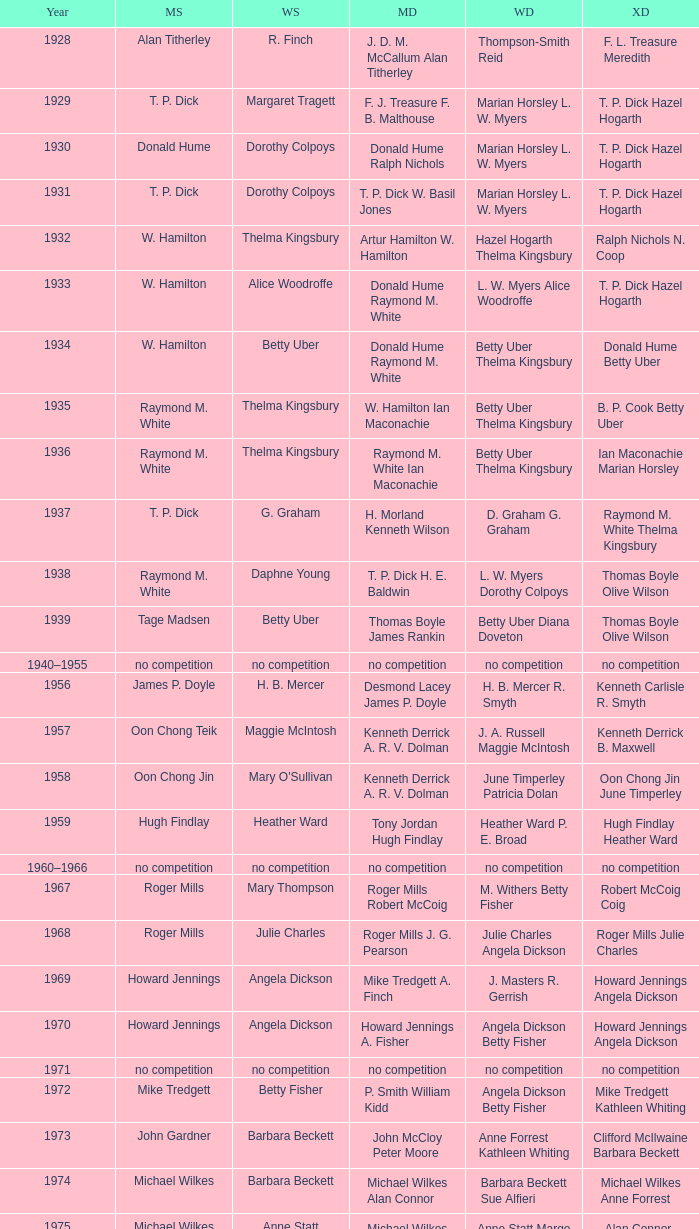In the year when david eddy eddy sutton clinched the men's doubles title and david eddy secured the men's singles championship, who were the victors in the women's doubles event? Anne Statt Jane Webster. Give me the full table as a dictionary. {'header': ['Year', 'MS', 'WS', 'MD', 'WD', 'XD'], 'rows': [['1928', 'Alan Titherley', 'R. Finch', 'J. D. M. McCallum Alan Titherley', 'Thompson-Smith Reid', 'F. L. Treasure Meredith'], ['1929', 'T. P. Dick', 'Margaret Tragett', 'F. J. Treasure F. B. Malthouse', 'Marian Horsley L. W. Myers', 'T. P. Dick Hazel Hogarth'], ['1930', 'Donald Hume', 'Dorothy Colpoys', 'Donald Hume Ralph Nichols', 'Marian Horsley L. W. Myers', 'T. P. Dick Hazel Hogarth'], ['1931', 'T. P. Dick', 'Dorothy Colpoys', 'T. P. Dick W. Basil Jones', 'Marian Horsley L. W. Myers', 'T. P. Dick Hazel Hogarth'], ['1932', 'W. Hamilton', 'Thelma Kingsbury', 'Artur Hamilton W. Hamilton', 'Hazel Hogarth Thelma Kingsbury', 'Ralph Nichols N. Coop'], ['1933', 'W. Hamilton', 'Alice Woodroffe', 'Donald Hume Raymond M. White', 'L. W. Myers Alice Woodroffe', 'T. P. Dick Hazel Hogarth'], ['1934', 'W. Hamilton', 'Betty Uber', 'Donald Hume Raymond M. White', 'Betty Uber Thelma Kingsbury', 'Donald Hume Betty Uber'], ['1935', 'Raymond M. White', 'Thelma Kingsbury', 'W. Hamilton Ian Maconachie', 'Betty Uber Thelma Kingsbury', 'B. P. Cook Betty Uber'], ['1936', 'Raymond M. White', 'Thelma Kingsbury', 'Raymond M. White Ian Maconachie', 'Betty Uber Thelma Kingsbury', 'Ian Maconachie Marian Horsley'], ['1937', 'T. P. Dick', 'G. Graham', 'H. Morland Kenneth Wilson', 'D. Graham G. Graham', 'Raymond M. White Thelma Kingsbury'], ['1938', 'Raymond M. White', 'Daphne Young', 'T. P. Dick H. E. Baldwin', 'L. W. Myers Dorothy Colpoys', 'Thomas Boyle Olive Wilson'], ['1939', 'Tage Madsen', 'Betty Uber', 'Thomas Boyle James Rankin', 'Betty Uber Diana Doveton', 'Thomas Boyle Olive Wilson'], ['1940–1955', 'no competition', 'no competition', 'no competition', 'no competition', 'no competition'], ['1956', 'James P. Doyle', 'H. B. Mercer', 'Desmond Lacey James P. Doyle', 'H. B. Mercer R. Smyth', 'Kenneth Carlisle R. Smyth'], ['1957', 'Oon Chong Teik', 'Maggie McIntosh', 'Kenneth Derrick A. R. V. Dolman', 'J. A. Russell Maggie McIntosh', 'Kenneth Derrick B. Maxwell'], ['1958', 'Oon Chong Jin', "Mary O'Sullivan", 'Kenneth Derrick A. R. V. Dolman', 'June Timperley Patricia Dolan', 'Oon Chong Jin June Timperley'], ['1959', 'Hugh Findlay', 'Heather Ward', 'Tony Jordan Hugh Findlay', 'Heather Ward P. E. Broad', 'Hugh Findlay Heather Ward'], ['1960–1966', 'no competition', 'no competition', 'no competition', 'no competition', 'no competition'], ['1967', 'Roger Mills', 'Mary Thompson', 'Roger Mills Robert McCoig', 'M. Withers Betty Fisher', 'Robert McCoig Coig'], ['1968', 'Roger Mills', 'Julie Charles', 'Roger Mills J. G. Pearson', 'Julie Charles Angela Dickson', 'Roger Mills Julie Charles'], ['1969', 'Howard Jennings', 'Angela Dickson', 'Mike Tredgett A. Finch', 'J. Masters R. Gerrish', 'Howard Jennings Angela Dickson'], ['1970', 'Howard Jennings', 'Angela Dickson', 'Howard Jennings A. Fisher', 'Angela Dickson Betty Fisher', 'Howard Jennings Angela Dickson'], ['1971', 'no competition', 'no competition', 'no competition', 'no competition', 'no competition'], ['1972', 'Mike Tredgett', 'Betty Fisher', 'P. Smith William Kidd', 'Angela Dickson Betty Fisher', 'Mike Tredgett Kathleen Whiting'], ['1973', 'John Gardner', 'Barbara Beckett', 'John McCloy Peter Moore', 'Anne Forrest Kathleen Whiting', 'Clifford McIlwaine Barbara Beckett'], ['1974', 'Michael Wilkes', 'Barbara Beckett', 'Michael Wilkes Alan Connor', 'Barbara Beckett Sue Alfieri', 'Michael Wilkes Anne Forrest'], ['1975', 'Michael Wilkes', 'Anne Statt', 'Michael Wilkes Alan Connor', 'Anne Statt Margo Winter', 'Alan Connor Margo Winter'], ['1976', 'Kevin Jolly', 'Pat Davies', 'Tim Stokes Kevin Jolly', 'Angela Dickson Sue Brimble', 'Howard Jennings Angela Dickson'], ['1977', 'David Eddy', 'Paula Kilvington', 'David Eddy Eddy Sutton', 'Anne Statt Jane Webster', 'David Eddy Barbara Giles'], ['1978', 'Mike Tredgett', 'Gillian Gilks', 'David Eddy Eddy Sutton', 'Barbara Sutton Marjan Ridder', 'Elliot Stuart Gillian Gilks'], ['1979', 'Kevin Jolly', 'Nora Perry', 'Ray Stevens Mike Tredgett', 'Barbara Sutton Nora Perry', 'Mike Tredgett Nora Perry'], ['1980', 'Thomas Kihlström', 'Jane Webster', 'Thomas Kihlström Bengt Fröman', 'Jane Webster Karen Puttick', 'Billy Gilliland Karen Puttick'], ['1981', 'Ray Stevens', 'Gillian Gilks', 'Ray Stevens Mike Tredgett', 'Gillian Gilks Paula Kilvington', 'Mike Tredgett Nora Perry'], ['1982', 'Steve Baddeley', 'Karen Bridge', 'David Eddy Eddy Sutton', 'Karen Chapman Sally Podger', 'Billy Gilliland Karen Chapman'], ['1983', 'Steve Butler', 'Sally Podger', 'Mike Tredgett Dipak Tailor', 'Nora Perry Jane Webster', 'Dipak Tailor Nora Perry'], ['1984', 'Steve Butler', 'Karen Beckman', 'Mike Tredgett Martin Dew', 'Helen Troke Karen Chapman', 'Mike Tredgett Karen Chapman'], ['1985', 'Morten Frost', 'Charlotte Hattens', 'Billy Gilliland Dan Travers', 'Gillian Gilks Helen Troke', 'Martin Dew Gillian Gilks'], ['1986', 'Darren Hall', 'Fiona Elliott', 'Martin Dew Dipak Tailor', 'Karen Beckman Sara Halsall', 'Jesper Knudsen Nettie Nielsen'], ['1987', 'Darren Hall', 'Fiona Elliott', 'Martin Dew Darren Hall', 'Karen Beckman Sara Halsall', 'Martin Dew Gillian Gilks'], ['1988', 'Vimal Kumar', 'Lee Jung-mi', 'Richard Outterside Mike Brown', 'Fiona Elliott Sara Halsall', 'Martin Dew Gillian Gilks'], ['1989', 'Darren Hall', 'Bang Soo-hyun', 'Nick Ponting Dave Wright', 'Karen Beckman Sara Sankey', 'Mike Brown Jillian Wallwork'], ['1990', 'Mathew Smith', 'Joanne Muggeridge', 'Nick Ponting Dave Wright', 'Karen Chapman Sara Sankey', 'Dave Wright Claire Palmer'], ['1991', 'Vimal Kumar', 'Denyse Julien', 'Nick Ponting Dave Wright', 'Cheryl Johnson Julie Bradbury', 'Nick Ponting Joanne Wright'], ['1992', 'Wei Yan', 'Fiona Smith', 'Michael Adams Chris Rees', 'Denyse Julien Doris Piché', 'Andy Goode Joanne Wright'], ['1993', 'Anders Nielsen', 'Sue Louis Lane', 'Nick Ponting Dave Wright', 'Julie Bradbury Sara Sankey', 'Nick Ponting Joanne Wright'], ['1994', 'Darren Hall', 'Marina Andrievskaya', 'Michael Adams Simon Archer', 'Julie Bradbury Joanne Wright', 'Chris Hunt Joanne Wright'], ['1995', 'Peter Rasmussen', 'Denyse Julien', 'Andrei Andropov Nikolai Zuyev', 'Julie Bradbury Joanne Wright', 'Nick Ponting Joanne Wright'], ['1996', 'Colin Haughton', 'Elena Rybkina', 'Andrei Andropov Nikolai Zuyev', 'Elena Rybkina Marina Yakusheva', 'Nikolai Zuyev Marina Yakusheva'], ['1997', 'Chris Bruil', 'Kelly Morgan', 'Ian Pearson James Anderson', 'Nicole van Hooren Brenda Conijn', 'Quinten van Dalm Nicole van Hooren'], ['1998', 'Dicky Palyama', 'Brenda Beenhakker', 'James Anderson Ian Sullivan', 'Sara Sankey Ella Tripp', 'James Anderson Sara Sankey'], ['1999', 'Daniel Eriksson', 'Marina Andrievskaya', 'Joachim Tesche Jean-Philippe Goyette', 'Marina Andrievskaya Catrine Bengtsson', 'Henrik Andersson Marina Andrievskaya'], ['2000', 'Richard Vaughan', 'Marina Yakusheva', 'Joachim Andersson Peter Axelsson', 'Irina Ruslyakova Marina Yakusheva', 'Peter Jeffrey Joanne Davies'], ['2001', 'Irwansyah', 'Brenda Beenhakker', 'Vincent Laigle Svetoslav Stoyanov', 'Sara Sankey Ella Tripp', 'Nikolai Zuyev Marina Yakusheva'], ['2002', 'Irwansyah', 'Karina de Wit', 'Nikolai Zuyev Stanislav Pukhov', 'Ella Tripp Joanne Wright', 'Nikolai Zuyev Marina Yakusheva'], ['2003', 'Irwansyah', 'Ella Karachkova', 'Ashley Thilthorpe Kristian Roebuck', 'Ella Karachkova Anastasia Russkikh', 'Alexandr Russkikh Anastasia Russkikh'], ['2004', 'Nathan Rice', 'Petya Nedelcheva', 'Reuben Gordown Aji Basuki Sindoro', 'Petya Nedelcheva Yuan Wemyss', 'Matthew Hughes Kelly Morgan'], ['2005', 'Chetan Anand', 'Eleanor Cox', 'Andrew Ellis Dean George', 'Hayley Connor Heather Olver', 'Valiyaveetil Diju Jwala Gutta'], ['2006', 'Irwansyah', 'Huang Chia-chi', 'Matthew Hughes Martyn Lewis', 'Natalie Munt Mariana Agathangelou', 'Kristian Roebuck Natalie Munt'], ['2007', 'Marc Zwiebler', 'Jill Pittard', 'Wojciech Szkudlarczyk Adam Cwalina', 'Chloe Magee Bing Huang', 'Wojciech Szkudlarczyk Malgorzata Kurdelska'], ['2008', 'Brice Leverdez', 'Kati Tolmoff', 'Andrew Bowman Martyn Lewis', 'Mariana Agathangelou Jillie Cooper', 'Watson Briggs Jillie Cooper'], ['2009', 'Kristian Nielsen', 'Tatjana Bibik', 'Vitaliy Durkin Alexandr Nikolaenko', 'Valeria Sorokina Nina Vislova', 'Vitaliy Durkin Nina Vislova'], ['2010', 'Pablo Abián', 'Anita Raj Kaur', 'Peter Käsbauer Josche Zurwonne', 'Joanne Quay Swee Ling Anita Raj Kaur', 'Peter Käsbauer Johanna Goliszewski'], ['2011', 'Niluka Karunaratne', 'Nicole Schaller', 'Chris Coles Matthew Nottingham', 'Ng Hui Ern Ng Hui Lin', 'Martin Campbell Ng Hui Lin'], ['2012', 'Chou Tien-chen', 'Chiang Mei-hui', 'Marcus Ellis Paul Van Rietvelde', 'Gabrielle White Lauren Smith', 'Marcus Ellis Gabrielle White']]} 